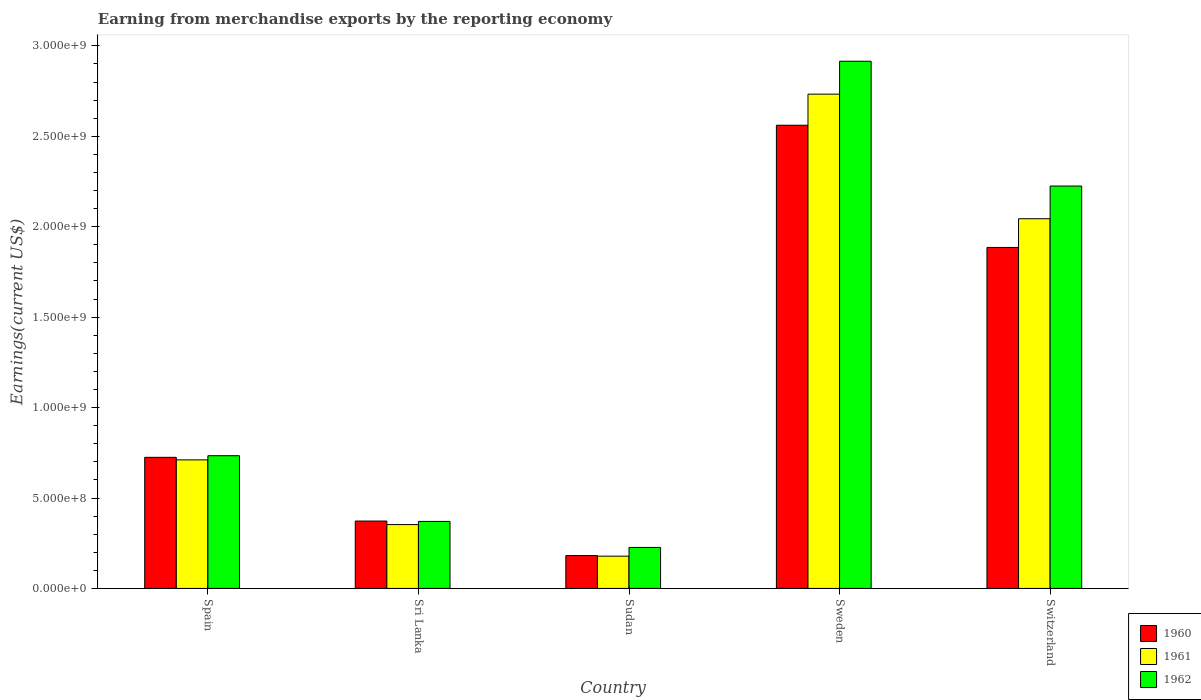How many groups of bars are there?
Provide a succinct answer. 5. Are the number of bars per tick equal to the number of legend labels?
Provide a short and direct response. Yes. Are the number of bars on each tick of the X-axis equal?
Offer a very short reply. Yes. What is the amount earned from merchandise exports in 1961 in Spain?
Make the answer very short. 7.11e+08. Across all countries, what is the maximum amount earned from merchandise exports in 1962?
Make the answer very short. 2.92e+09. Across all countries, what is the minimum amount earned from merchandise exports in 1962?
Ensure brevity in your answer.  2.27e+08. In which country was the amount earned from merchandise exports in 1961 maximum?
Keep it short and to the point. Sweden. In which country was the amount earned from merchandise exports in 1961 minimum?
Your answer should be compact. Sudan. What is the total amount earned from merchandise exports in 1962 in the graph?
Give a very brief answer. 6.47e+09. What is the difference between the amount earned from merchandise exports in 1961 in Sudan and that in Sweden?
Offer a very short reply. -2.55e+09. What is the difference between the amount earned from merchandise exports in 1960 in Switzerland and the amount earned from merchandise exports in 1962 in Sri Lanka?
Provide a short and direct response. 1.51e+09. What is the average amount earned from merchandise exports in 1962 per country?
Make the answer very short. 1.29e+09. What is the difference between the amount earned from merchandise exports of/in 1961 and amount earned from merchandise exports of/in 1962 in Sri Lanka?
Offer a terse response. -1.76e+07. What is the ratio of the amount earned from merchandise exports in 1962 in Sri Lanka to that in Sweden?
Provide a succinct answer. 0.13. Is the amount earned from merchandise exports in 1961 in Sudan less than that in Switzerland?
Make the answer very short. Yes. What is the difference between the highest and the second highest amount earned from merchandise exports in 1960?
Provide a short and direct response. 6.76e+08. What is the difference between the highest and the lowest amount earned from merchandise exports in 1960?
Give a very brief answer. 2.38e+09. Is the sum of the amount earned from merchandise exports in 1962 in Sri Lanka and Switzerland greater than the maximum amount earned from merchandise exports in 1961 across all countries?
Make the answer very short. No. What does the 3rd bar from the left in Spain represents?
Your answer should be compact. 1962. How many bars are there?
Your answer should be very brief. 15. What is the difference between two consecutive major ticks on the Y-axis?
Make the answer very short. 5.00e+08. Does the graph contain grids?
Your response must be concise. No. How many legend labels are there?
Provide a short and direct response. 3. What is the title of the graph?
Your response must be concise. Earning from merchandise exports by the reporting economy. Does "1970" appear as one of the legend labels in the graph?
Your answer should be compact. No. What is the label or title of the Y-axis?
Ensure brevity in your answer.  Earnings(current US$). What is the Earnings(current US$) of 1960 in Spain?
Your answer should be very brief. 7.25e+08. What is the Earnings(current US$) in 1961 in Spain?
Offer a terse response. 7.11e+08. What is the Earnings(current US$) of 1962 in Spain?
Your answer should be compact. 7.34e+08. What is the Earnings(current US$) of 1960 in Sri Lanka?
Offer a terse response. 3.73e+08. What is the Earnings(current US$) in 1961 in Sri Lanka?
Your answer should be compact. 3.53e+08. What is the Earnings(current US$) of 1962 in Sri Lanka?
Offer a terse response. 3.71e+08. What is the Earnings(current US$) in 1960 in Sudan?
Give a very brief answer. 1.82e+08. What is the Earnings(current US$) of 1961 in Sudan?
Provide a succinct answer. 1.78e+08. What is the Earnings(current US$) of 1962 in Sudan?
Keep it short and to the point. 2.27e+08. What is the Earnings(current US$) in 1960 in Sweden?
Your answer should be very brief. 2.56e+09. What is the Earnings(current US$) in 1961 in Sweden?
Make the answer very short. 2.73e+09. What is the Earnings(current US$) of 1962 in Sweden?
Your answer should be compact. 2.92e+09. What is the Earnings(current US$) in 1960 in Switzerland?
Provide a short and direct response. 1.89e+09. What is the Earnings(current US$) in 1961 in Switzerland?
Make the answer very short. 2.04e+09. What is the Earnings(current US$) of 1962 in Switzerland?
Keep it short and to the point. 2.22e+09. Across all countries, what is the maximum Earnings(current US$) in 1960?
Your response must be concise. 2.56e+09. Across all countries, what is the maximum Earnings(current US$) in 1961?
Offer a very short reply. 2.73e+09. Across all countries, what is the maximum Earnings(current US$) in 1962?
Make the answer very short. 2.92e+09. Across all countries, what is the minimum Earnings(current US$) of 1960?
Offer a terse response. 1.82e+08. Across all countries, what is the minimum Earnings(current US$) in 1961?
Your response must be concise. 1.78e+08. Across all countries, what is the minimum Earnings(current US$) in 1962?
Offer a very short reply. 2.27e+08. What is the total Earnings(current US$) of 1960 in the graph?
Make the answer very short. 5.73e+09. What is the total Earnings(current US$) of 1961 in the graph?
Offer a terse response. 6.02e+09. What is the total Earnings(current US$) in 1962 in the graph?
Your answer should be compact. 6.47e+09. What is the difference between the Earnings(current US$) of 1960 in Spain and that in Sri Lanka?
Your answer should be very brief. 3.52e+08. What is the difference between the Earnings(current US$) of 1961 in Spain and that in Sri Lanka?
Provide a short and direct response. 3.58e+08. What is the difference between the Earnings(current US$) in 1962 in Spain and that in Sri Lanka?
Your answer should be very brief. 3.63e+08. What is the difference between the Earnings(current US$) in 1960 in Spain and that in Sudan?
Offer a very short reply. 5.43e+08. What is the difference between the Earnings(current US$) in 1961 in Spain and that in Sudan?
Offer a terse response. 5.32e+08. What is the difference between the Earnings(current US$) in 1962 in Spain and that in Sudan?
Offer a very short reply. 5.07e+08. What is the difference between the Earnings(current US$) of 1960 in Spain and that in Sweden?
Your answer should be compact. -1.84e+09. What is the difference between the Earnings(current US$) in 1961 in Spain and that in Sweden?
Provide a succinct answer. -2.02e+09. What is the difference between the Earnings(current US$) in 1962 in Spain and that in Sweden?
Offer a terse response. -2.18e+09. What is the difference between the Earnings(current US$) of 1960 in Spain and that in Switzerland?
Provide a short and direct response. -1.16e+09. What is the difference between the Earnings(current US$) in 1961 in Spain and that in Switzerland?
Offer a terse response. -1.33e+09. What is the difference between the Earnings(current US$) of 1962 in Spain and that in Switzerland?
Provide a succinct answer. -1.49e+09. What is the difference between the Earnings(current US$) of 1960 in Sri Lanka and that in Sudan?
Give a very brief answer. 1.91e+08. What is the difference between the Earnings(current US$) in 1961 in Sri Lanka and that in Sudan?
Provide a succinct answer. 1.75e+08. What is the difference between the Earnings(current US$) in 1962 in Sri Lanka and that in Sudan?
Keep it short and to the point. 1.44e+08. What is the difference between the Earnings(current US$) of 1960 in Sri Lanka and that in Sweden?
Your answer should be very brief. -2.19e+09. What is the difference between the Earnings(current US$) in 1961 in Sri Lanka and that in Sweden?
Provide a short and direct response. -2.38e+09. What is the difference between the Earnings(current US$) in 1962 in Sri Lanka and that in Sweden?
Provide a short and direct response. -2.54e+09. What is the difference between the Earnings(current US$) in 1960 in Sri Lanka and that in Switzerland?
Your response must be concise. -1.51e+09. What is the difference between the Earnings(current US$) of 1961 in Sri Lanka and that in Switzerland?
Your answer should be very brief. -1.69e+09. What is the difference between the Earnings(current US$) of 1962 in Sri Lanka and that in Switzerland?
Keep it short and to the point. -1.85e+09. What is the difference between the Earnings(current US$) in 1960 in Sudan and that in Sweden?
Your answer should be compact. -2.38e+09. What is the difference between the Earnings(current US$) in 1961 in Sudan and that in Sweden?
Your answer should be compact. -2.55e+09. What is the difference between the Earnings(current US$) of 1962 in Sudan and that in Sweden?
Provide a succinct answer. -2.69e+09. What is the difference between the Earnings(current US$) of 1960 in Sudan and that in Switzerland?
Offer a terse response. -1.70e+09. What is the difference between the Earnings(current US$) in 1961 in Sudan and that in Switzerland?
Make the answer very short. -1.87e+09. What is the difference between the Earnings(current US$) of 1962 in Sudan and that in Switzerland?
Provide a short and direct response. -2.00e+09. What is the difference between the Earnings(current US$) of 1960 in Sweden and that in Switzerland?
Ensure brevity in your answer.  6.76e+08. What is the difference between the Earnings(current US$) of 1961 in Sweden and that in Switzerland?
Keep it short and to the point. 6.89e+08. What is the difference between the Earnings(current US$) of 1962 in Sweden and that in Switzerland?
Your response must be concise. 6.90e+08. What is the difference between the Earnings(current US$) of 1960 in Spain and the Earnings(current US$) of 1961 in Sri Lanka?
Make the answer very short. 3.72e+08. What is the difference between the Earnings(current US$) in 1960 in Spain and the Earnings(current US$) in 1962 in Sri Lanka?
Provide a short and direct response. 3.54e+08. What is the difference between the Earnings(current US$) of 1961 in Spain and the Earnings(current US$) of 1962 in Sri Lanka?
Offer a very short reply. 3.40e+08. What is the difference between the Earnings(current US$) of 1960 in Spain and the Earnings(current US$) of 1961 in Sudan?
Ensure brevity in your answer.  5.46e+08. What is the difference between the Earnings(current US$) of 1960 in Spain and the Earnings(current US$) of 1962 in Sudan?
Ensure brevity in your answer.  4.98e+08. What is the difference between the Earnings(current US$) of 1961 in Spain and the Earnings(current US$) of 1962 in Sudan?
Make the answer very short. 4.84e+08. What is the difference between the Earnings(current US$) of 1960 in Spain and the Earnings(current US$) of 1961 in Sweden?
Your answer should be compact. -2.01e+09. What is the difference between the Earnings(current US$) of 1960 in Spain and the Earnings(current US$) of 1962 in Sweden?
Make the answer very short. -2.19e+09. What is the difference between the Earnings(current US$) of 1961 in Spain and the Earnings(current US$) of 1962 in Sweden?
Offer a very short reply. -2.20e+09. What is the difference between the Earnings(current US$) of 1960 in Spain and the Earnings(current US$) of 1961 in Switzerland?
Your response must be concise. -1.32e+09. What is the difference between the Earnings(current US$) of 1960 in Spain and the Earnings(current US$) of 1962 in Switzerland?
Provide a short and direct response. -1.50e+09. What is the difference between the Earnings(current US$) in 1961 in Spain and the Earnings(current US$) in 1962 in Switzerland?
Offer a terse response. -1.51e+09. What is the difference between the Earnings(current US$) of 1960 in Sri Lanka and the Earnings(current US$) of 1961 in Sudan?
Keep it short and to the point. 1.94e+08. What is the difference between the Earnings(current US$) in 1960 in Sri Lanka and the Earnings(current US$) in 1962 in Sudan?
Your answer should be compact. 1.46e+08. What is the difference between the Earnings(current US$) of 1961 in Sri Lanka and the Earnings(current US$) of 1962 in Sudan?
Offer a terse response. 1.26e+08. What is the difference between the Earnings(current US$) in 1960 in Sri Lanka and the Earnings(current US$) in 1961 in Sweden?
Your response must be concise. -2.36e+09. What is the difference between the Earnings(current US$) in 1960 in Sri Lanka and the Earnings(current US$) in 1962 in Sweden?
Your answer should be compact. -2.54e+09. What is the difference between the Earnings(current US$) in 1961 in Sri Lanka and the Earnings(current US$) in 1962 in Sweden?
Provide a short and direct response. -2.56e+09. What is the difference between the Earnings(current US$) of 1960 in Sri Lanka and the Earnings(current US$) of 1961 in Switzerland?
Give a very brief answer. -1.67e+09. What is the difference between the Earnings(current US$) of 1960 in Sri Lanka and the Earnings(current US$) of 1962 in Switzerland?
Ensure brevity in your answer.  -1.85e+09. What is the difference between the Earnings(current US$) of 1961 in Sri Lanka and the Earnings(current US$) of 1962 in Switzerland?
Provide a short and direct response. -1.87e+09. What is the difference between the Earnings(current US$) in 1960 in Sudan and the Earnings(current US$) in 1961 in Sweden?
Your response must be concise. -2.55e+09. What is the difference between the Earnings(current US$) of 1960 in Sudan and the Earnings(current US$) of 1962 in Sweden?
Ensure brevity in your answer.  -2.73e+09. What is the difference between the Earnings(current US$) of 1961 in Sudan and the Earnings(current US$) of 1962 in Sweden?
Provide a short and direct response. -2.74e+09. What is the difference between the Earnings(current US$) in 1960 in Sudan and the Earnings(current US$) in 1961 in Switzerland?
Your response must be concise. -1.86e+09. What is the difference between the Earnings(current US$) of 1960 in Sudan and the Earnings(current US$) of 1962 in Switzerland?
Your answer should be very brief. -2.04e+09. What is the difference between the Earnings(current US$) in 1961 in Sudan and the Earnings(current US$) in 1962 in Switzerland?
Your answer should be very brief. -2.05e+09. What is the difference between the Earnings(current US$) in 1960 in Sweden and the Earnings(current US$) in 1961 in Switzerland?
Your answer should be compact. 5.17e+08. What is the difference between the Earnings(current US$) in 1960 in Sweden and the Earnings(current US$) in 1962 in Switzerland?
Your response must be concise. 3.36e+08. What is the difference between the Earnings(current US$) of 1961 in Sweden and the Earnings(current US$) of 1962 in Switzerland?
Keep it short and to the point. 5.08e+08. What is the average Earnings(current US$) of 1960 per country?
Provide a succinct answer. 1.15e+09. What is the average Earnings(current US$) in 1961 per country?
Your answer should be very brief. 1.20e+09. What is the average Earnings(current US$) of 1962 per country?
Your response must be concise. 1.29e+09. What is the difference between the Earnings(current US$) in 1960 and Earnings(current US$) in 1961 in Spain?
Your answer should be very brief. 1.40e+07. What is the difference between the Earnings(current US$) of 1960 and Earnings(current US$) of 1962 in Spain?
Give a very brief answer. -9.00e+06. What is the difference between the Earnings(current US$) in 1961 and Earnings(current US$) in 1962 in Spain?
Offer a very short reply. -2.30e+07. What is the difference between the Earnings(current US$) in 1960 and Earnings(current US$) in 1961 in Sri Lanka?
Keep it short and to the point. 1.96e+07. What is the difference between the Earnings(current US$) of 1960 and Earnings(current US$) of 1962 in Sri Lanka?
Offer a terse response. 2.00e+06. What is the difference between the Earnings(current US$) of 1961 and Earnings(current US$) of 1962 in Sri Lanka?
Offer a terse response. -1.76e+07. What is the difference between the Earnings(current US$) in 1960 and Earnings(current US$) in 1961 in Sudan?
Your answer should be compact. 3.30e+06. What is the difference between the Earnings(current US$) of 1960 and Earnings(current US$) of 1962 in Sudan?
Your answer should be very brief. -4.49e+07. What is the difference between the Earnings(current US$) in 1961 and Earnings(current US$) in 1962 in Sudan?
Offer a very short reply. -4.82e+07. What is the difference between the Earnings(current US$) in 1960 and Earnings(current US$) in 1961 in Sweden?
Your response must be concise. -1.72e+08. What is the difference between the Earnings(current US$) in 1960 and Earnings(current US$) in 1962 in Sweden?
Make the answer very short. -3.54e+08. What is the difference between the Earnings(current US$) in 1961 and Earnings(current US$) in 1962 in Sweden?
Make the answer very short. -1.82e+08. What is the difference between the Earnings(current US$) of 1960 and Earnings(current US$) of 1961 in Switzerland?
Offer a terse response. -1.59e+08. What is the difference between the Earnings(current US$) in 1960 and Earnings(current US$) in 1962 in Switzerland?
Offer a very short reply. -3.40e+08. What is the difference between the Earnings(current US$) of 1961 and Earnings(current US$) of 1962 in Switzerland?
Ensure brevity in your answer.  -1.81e+08. What is the ratio of the Earnings(current US$) in 1960 in Spain to that in Sri Lanka?
Keep it short and to the point. 1.95. What is the ratio of the Earnings(current US$) in 1961 in Spain to that in Sri Lanka?
Provide a short and direct response. 2.01. What is the ratio of the Earnings(current US$) in 1962 in Spain to that in Sri Lanka?
Your answer should be compact. 1.98. What is the ratio of the Earnings(current US$) of 1960 in Spain to that in Sudan?
Make the answer very short. 3.99. What is the ratio of the Earnings(current US$) of 1961 in Spain to that in Sudan?
Your answer should be very brief. 3.98. What is the ratio of the Earnings(current US$) of 1962 in Spain to that in Sudan?
Provide a succinct answer. 3.24. What is the ratio of the Earnings(current US$) in 1960 in Spain to that in Sweden?
Provide a short and direct response. 0.28. What is the ratio of the Earnings(current US$) of 1961 in Spain to that in Sweden?
Keep it short and to the point. 0.26. What is the ratio of the Earnings(current US$) in 1962 in Spain to that in Sweden?
Offer a very short reply. 0.25. What is the ratio of the Earnings(current US$) of 1960 in Spain to that in Switzerland?
Give a very brief answer. 0.38. What is the ratio of the Earnings(current US$) in 1961 in Spain to that in Switzerland?
Offer a very short reply. 0.35. What is the ratio of the Earnings(current US$) in 1962 in Spain to that in Switzerland?
Make the answer very short. 0.33. What is the ratio of the Earnings(current US$) in 1960 in Sri Lanka to that in Sudan?
Provide a short and direct response. 2.05. What is the ratio of the Earnings(current US$) in 1961 in Sri Lanka to that in Sudan?
Keep it short and to the point. 1.98. What is the ratio of the Earnings(current US$) in 1962 in Sri Lanka to that in Sudan?
Offer a very short reply. 1.64. What is the ratio of the Earnings(current US$) of 1960 in Sri Lanka to that in Sweden?
Your answer should be compact. 0.15. What is the ratio of the Earnings(current US$) of 1961 in Sri Lanka to that in Sweden?
Offer a very short reply. 0.13. What is the ratio of the Earnings(current US$) in 1962 in Sri Lanka to that in Sweden?
Your answer should be very brief. 0.13. What is the ratio of the Earnings(current US$) of 1960 in Sri Lanka to that in Switzerland?
Give a very brief answer. 0.2. What is the ratio of the Earnings(current US$) in 1961 in Sri Lanka to that in Switzerland?
Provide a succinct answer. 0.17. What is the ratio of the Earnings(current US$) of 1962 in Sri Lanka to that in Switzerland?
Keep it short and to the point. 0.17. What is the ratio of the Earnings(current US$) of 1960 in Sudan to that in Sweden?
Your response must be concise. 0.07. What is the ratio of the Earnings(current US$) in 1961 in Sudan to that in Sweden?
Provide a short and direct response. 0.07. What is the ratio of the Earnings(current US$) of 1962 in Sudan to that in Sweden?
Provide a short and direct response. 0.08. What is the ratio of the Earnings(current US$) in 1960 in Sudan to that in Switzerland?
Make the answer very short. 0.1. What is the ratio of the Earnings(current US$) of 1961 in Sudan to that in Switzerland?
Your answer should be compact. 0.09. What is the ratio of the Earnings(current US$) of 1962 in Sudan to that in Switzerland?
Give a very brief answer. 0.1. What is the ratio of the Earnings(current US$) in 1960 in Sweden to that in Switzerland?
Keep it short and to the point. 1.36. What is the ratio of the Earnings(current US$) of 1961 in Sweden to that in Switzerland?
Offer a terse response. 1.34. What is the ratio of the Earnings(current US$) of 1962 in Sweden to that in Switzerland?
Offer a very short reply. 1.31. What is the difference between the highest and the second highest Earnings(current US$) of 1960?
Provide a succinct answer. 6.76e+08. What is the difference between the highest and the second highest Earnings(current US$) in 1961?
Your answer should be very brief. 6.89e+08. What is the difference between the highest and the second highest Earnings(current US$) in 1962?
Provide a succinct answer. 6.90e+08. What is the difference between the highest and the lowest Earnings(current US$) in 1960?
Make the answer very short. 2.38e+09. What is the difference between the highest and the lowest Earnings(current US$) of 1961?
Provide a short and direct response. 2.55e+09. What is the difference between the highest and the lowest Earnings(current US$) in 1962?
Ensure brevity in your answer.  2.69e+09. 